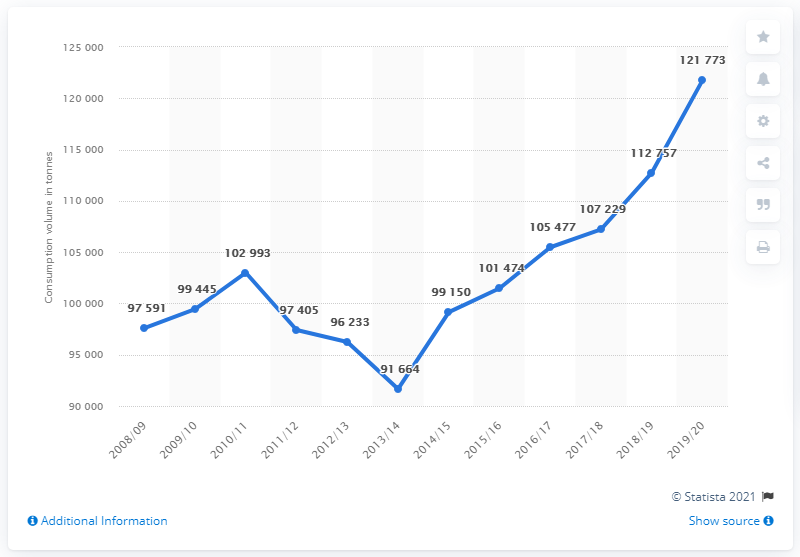Highlight a few significant elements in this photo. For how many years have the volume levels been below 98,000? In the year 2019/20, there was the highest volume of water. In 2019, there was a significant increase in the consumption of bananas in Austria compared to the previous year, with an increase of 121,733 metric tons. In the 2018/2019 fiscal year, the volume of bananas consumed in Austria was approximately 121,773 metric tons. 